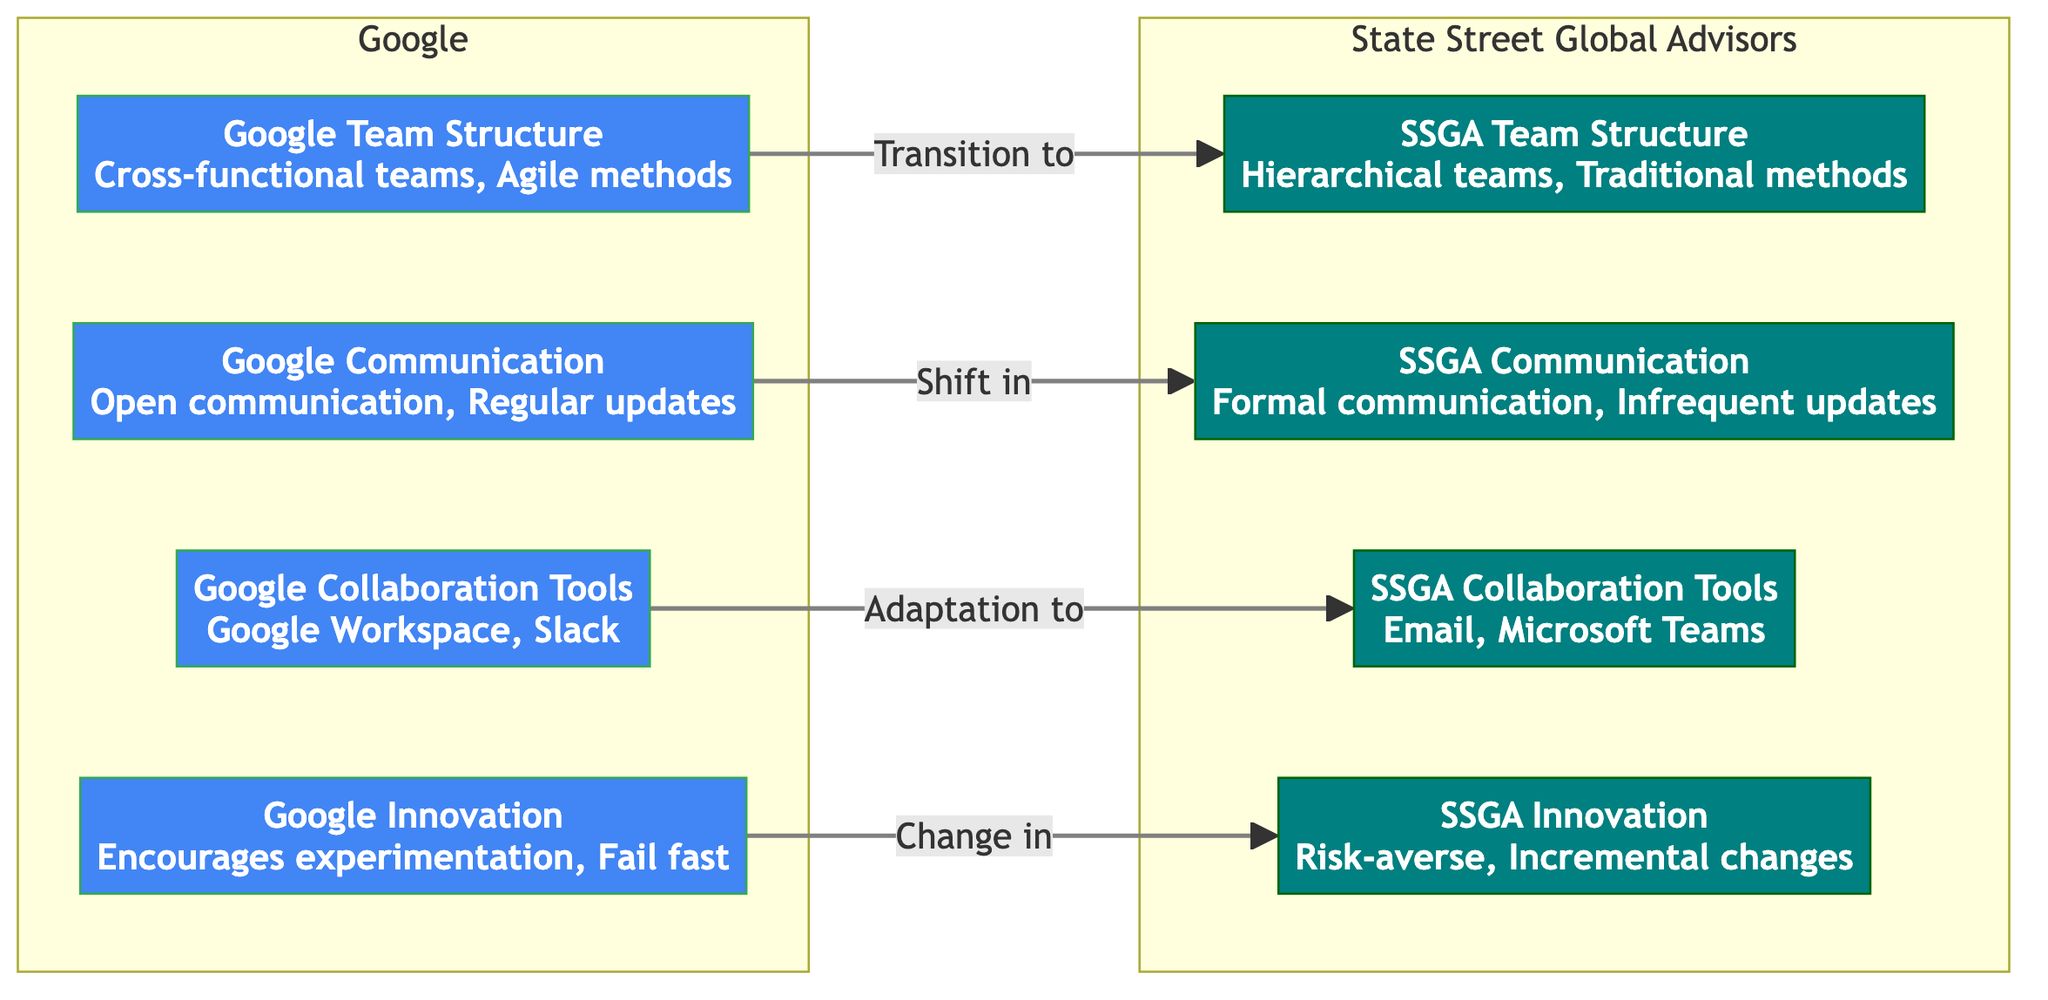What are the two team structures compared in the diagram? The diagram compares "Cross-functional teams, Agile methods" from Google with "Hierarchical teams, Traditional methods" from SSGA. These are noted in nodes A and E respectively.
Answer: Cross-functional teams, Agile methods; Hierarchical teams, Traditional methods What type of communication does Google practice? The diagram indicates that Google practices "Open communication, Regular updates". This information is present in node B.
Answer: Open communication, Regular updates How many distinct collaboration tools are mentioned for SSGA? In the SSGA section, there's only one collaboration tool mentioned: "Email, Microsoft Teams." This is shown in node G.
Answer: One What transition occurs between Google's innovation approach and SSGA's? The diagram shows a transition from "Encourages experimentation, Fail fast" at Google (node D) to "Risk-averse, Incremental changes" at SSGA (node H). This indicates the shift in innovation styles.
Answer: Encourages experimentation, Fail fast to Risk-averse, Incremental changes Which collaboration tool from Google is adapted to SSGA? The diagram indicates that "Google Workspace, Slack" (node C) is adapted to "Email, Microsoft Teams" (node G) in SSGA. This shift implies a change in the preferred tools for collaboration.
Answer: Google Workspace, Slack to Email, Microsoft Teams What is the nature of communication in SSGA? The diagram specifies that SSGA has "Formal communication, Infrequent updates." This is clearly indicated in node F.
Answer: Formal communication, Infrequent updates Which two aspects of the team structure are qualitatively different between Google and SSGA? The differences are in "Cross-functional teams, Agile methods" versus "Hierarchical teams, Traditional methods" respectively, focusing on flexibility versus a structured approach.
Answer: Team flexibility and structure How does Google's innovation philosophy differ from SSGA's? The diagram illustrates a contrast between "Encourages experimentation, Fail fast" for Google and "Risk-averse, Incremental changes" for SSGA, highlighting the differing approaches towards innovation and risk-taking.
Answer: Encourages experimentation, Fail fast vs Risk-averse, Incremental changes 